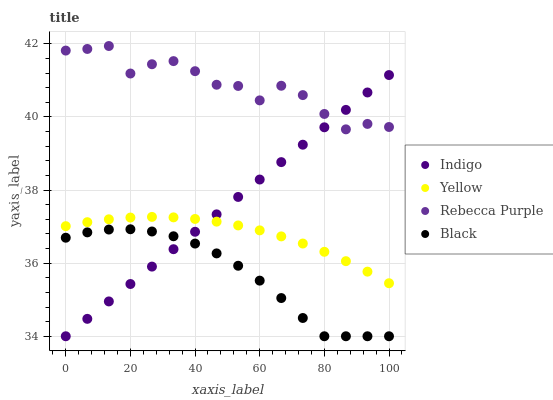Does Black have the minimum area under the curve?
Answer yes or no. Yes. Does Rebecca Purple have the maximum area under the curve?
Answer yes or no. Yes. Does Indigo have the minimum area under the curve?
Answer yes or no. No. Does Indigo have the maximum area under the curve?
Answer yes or no. No. Is Indigo the smoothest?
Answer yes or no. Yes. Is Rebecca Purple the roughest?
Answer yes or no. Yes. Is Rebecca Purple the smoothest?
Answer yes or no. No. Is Indigo the roughest?
Answer yes or no. No. Does Black have the lowest value?
Answer yes or no. Yes. Does Rebecca Purple have the lowest value?
Answer yes or no. No. Does Rebecca Purple have the highest value?
Answer yes or no. Yes. Does Indigo have the highest value?
Answer yes or no. No. Is Yellow less than Rebecca Purple?
Answer yes or no. Yes. Is Rebecca Purple greater than Black?
Answer yes or no. Yes. Does Black intersect Indigo?
Answer yes or no. Yes. Is Black less than Indigo?
Answer yes or no. No. Is Black greater than Indigo?
Answer yes or no. No. Does Yellow intersect Rebecca Purple?
Answer yes or no. No. 